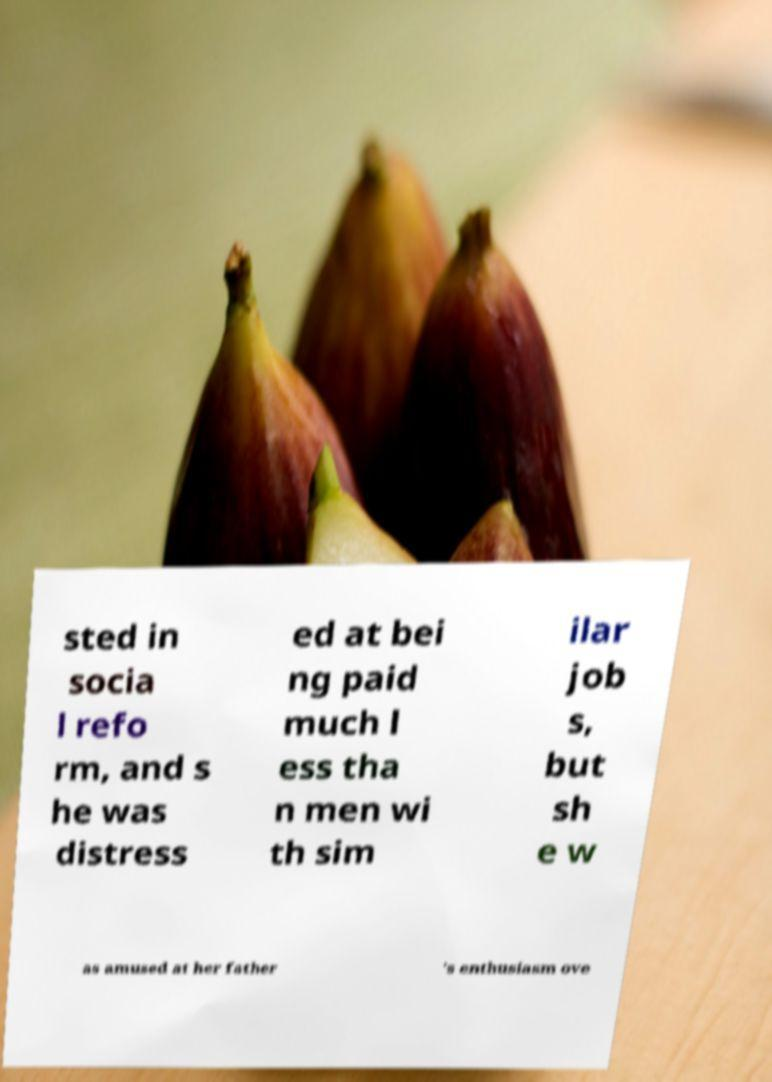Can you accurately transcribe the text from the provided image for me? sted in socia l refo rm, and s he was distress ed at bei ng paid much l ess tha n men wi th sim ilar job s, but sh e w as amused at her father 's enthusiasm ove 